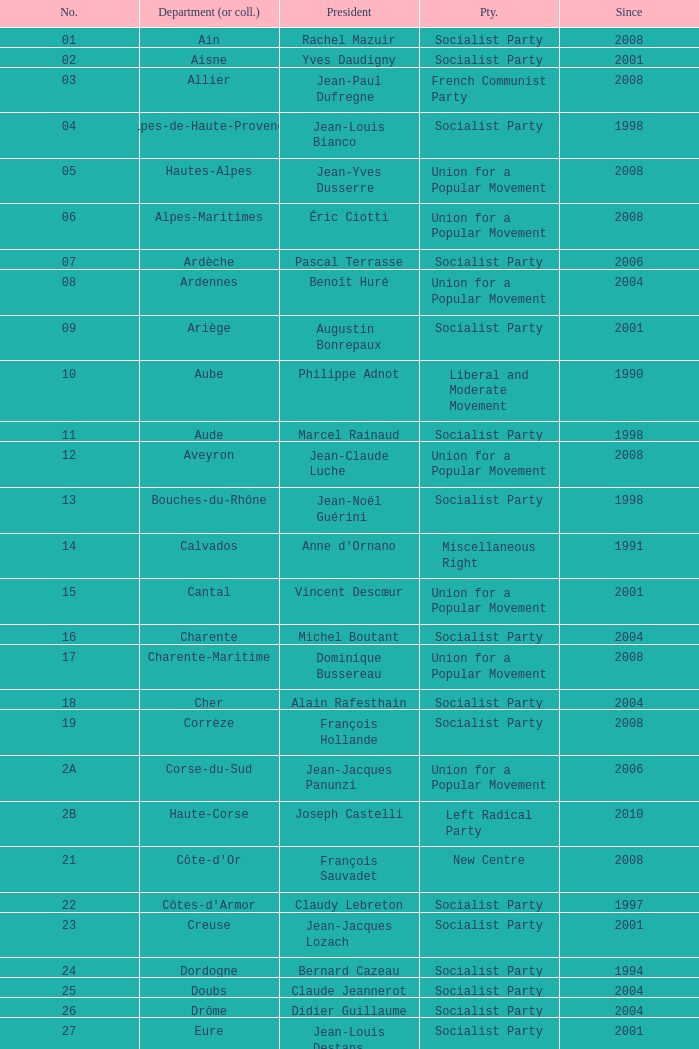Who is the president from the Union for a Popular Movement party that represents the Hautes-Alpes department? Jean-Yves Dusserre. 